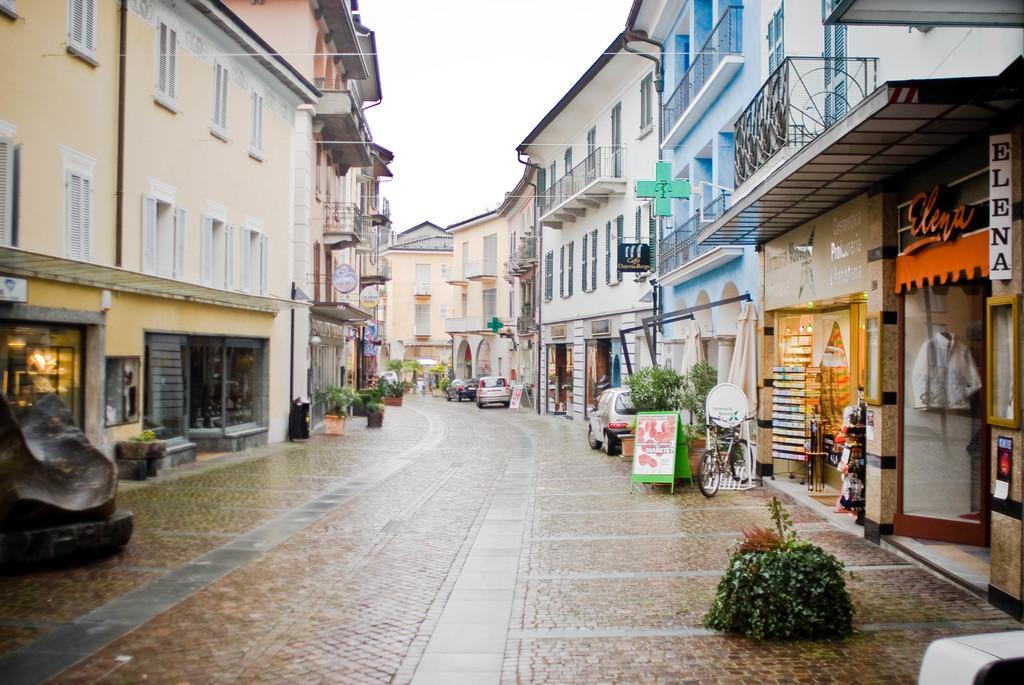Describe this image in one or two sentences. These are the buildings with the windows. Here is a bicycle and the cars, which are parked. I can see the shops. This looks like a name board, which is attached to the wall. I can see the flower pots with the plants in it. This is a board, which is placed on the road. Here is the sky. 